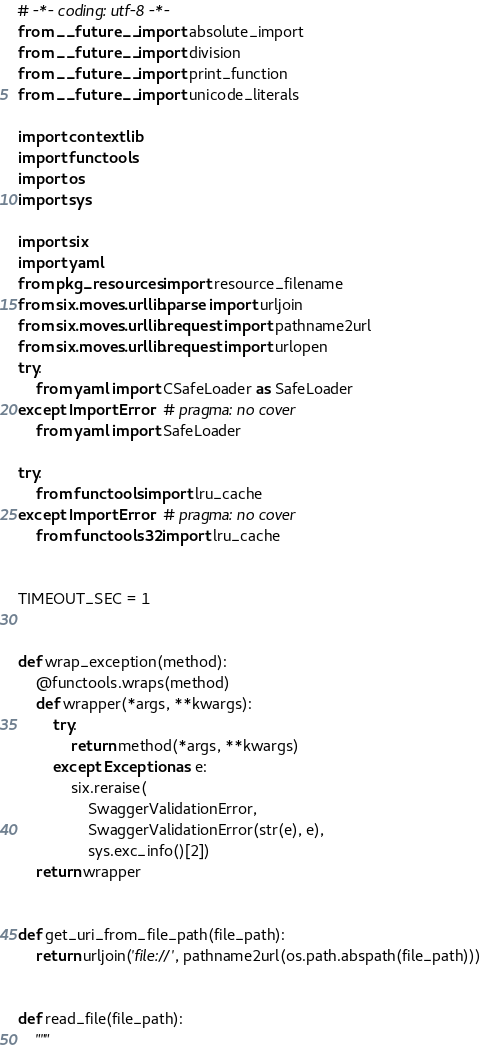<code> <loc_0><loc_0><loc_500><loc_500><_Python_># -*- coding: utf-8 -*-
from __future__ import absolute_import
from __future__ import division
from __future__ import print_function
from __future__ import unicode_literals

import contextlib
import functools
import os
import sys

import six
import yaml
from pkg_resources import resource_filename
from six.moves.urllib.parse import urljoin
from six.moves.urllib.request import pathname2url
from six.moves.urllib.request import urlopen
try:
    from yaml import CSafeLoader as SafeLoader
except ImportError:  # pragma: no cover
    from yaml import SafeLoader

try:
    from functools import lru_cache
except ImportError:  # pragma: no cover
    from functools32 import lru_cache


TIMEOUT_SEC = 1


def wrap_exception(method):
    @functools.wraps(method)
    def wrapper(*args, **kwargs):
        try:
            return method(*args, **kwargs)
        except Exception as e:
            six.reraise(
                SwaggerValidationError,
                SwaggerValidationError(str(e), e),
                sys.exc_info()[2])
    return wrapper


def get_uri_from_file_path(file_path):
    return urljoin('file://', pathname2url(os.path.abspath(file_path)))


def read_file(file_path):
    """</code> 